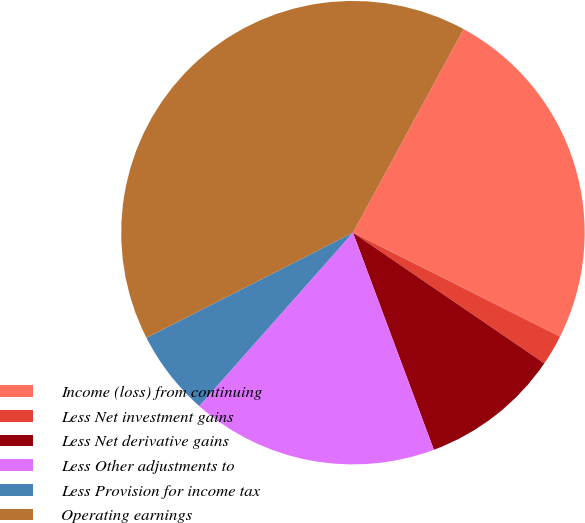<chart> <loc_0><loc_0><loc_500><loc_500><pie_chart><fcel>Income (loss) from continuing<fcel>Less Net investment gains<fcel>Less Net derivative gains<fcel>Less Other adjustments to<fcel>Less Provision for income tax<fcel>Operating earnings<nl><fcel>24.48%<fcel>2.13%<fcel>9.79%<fcel>17.22%<fcel>5.96%<fcel>40.42%<nl></chart> 